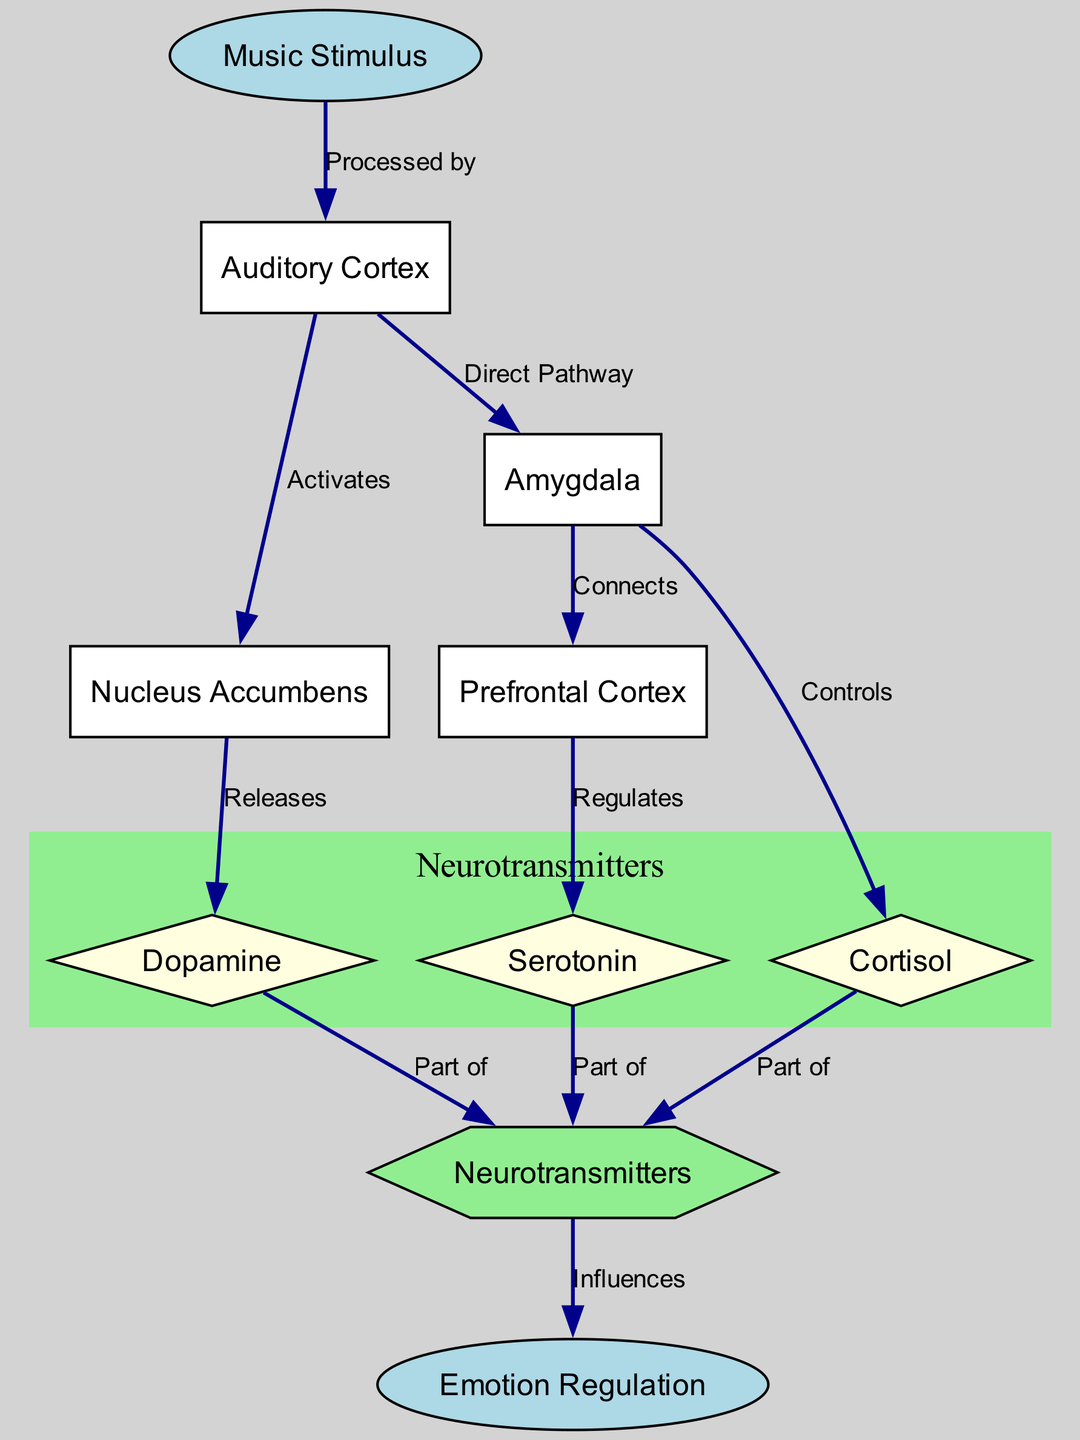What is the starting point of the diagram? The diagram starts with the node labeled "Music Stimulus," which indicates the origin of the biochemical mechanisms illustrated in the diagram.
Answer: Music Stimulus How many neurotransmitters are represented in the diagram? The diagram includes three neurotransmitters: Dopamine, Serotonin, and Cortisol, which can be counted from the nodes listed.
Answer: 3 What two nodes does the "Auditory Cortex" connect to directly? The "Auditory Cortex" connects to the "Nucleus Accumbens" and "Amygdala" based on the edges defined in the diagram.
Answer: Nucleus Accumbens, Amygdala What regulates Serotonin? The "Prefrontal Cortex" is shown to regulate Serotonin, as indicated by the directed edge pointing from "Prefrontal Cortex" to "Serotonin."
Answer: Prefrontal Cortex Which node directly influences Emotion Regulation? The node "Neurotransmitters" influences Emotion Regulation, as it is connected to the "Emotion Regulation" node with a directed edge showing its influence.
Answer: Neurotransmitters How does the "Music Stimulus" affect the "Nucleus Accumbens"? The "Music Stimulus" is processed by the "Auditory Cortex," which then activates the "Nucleus Accumbens," as per the sequence of connections shown in the diagram.
Answer: Activates What is the relationship between the "Amygdala" and "Cortisol"? The diagram indicates that the "Amygdala" controls "Cortisol," establishing a direct connection between these two nodes.
Answer: Controls Which neurotransmitter is released by the "Nucleus Accumbens"? The diagram specifies that the "Nucleus Accumbens" releases "Dopamine," directly linking these two nodes.
Answer: Dopamine How many direct connections does the "Amygdala" have? The "Amygdala" has two direct connections: one to the "Prefrontal Cortex" and another to "Cortisol," which can be counted from the associated edges.
Answer: 2 